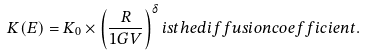Convert formula to latex. <formula><loc_0><loc_0><loc_500><loc_500>K ( E ) = K _ { 0 } \times \left ( \frac { R } { 1 G V } \right ) ^ { \delta } i s t h e d i f f u s i o n c o e f f i c i e n t .</formula> 